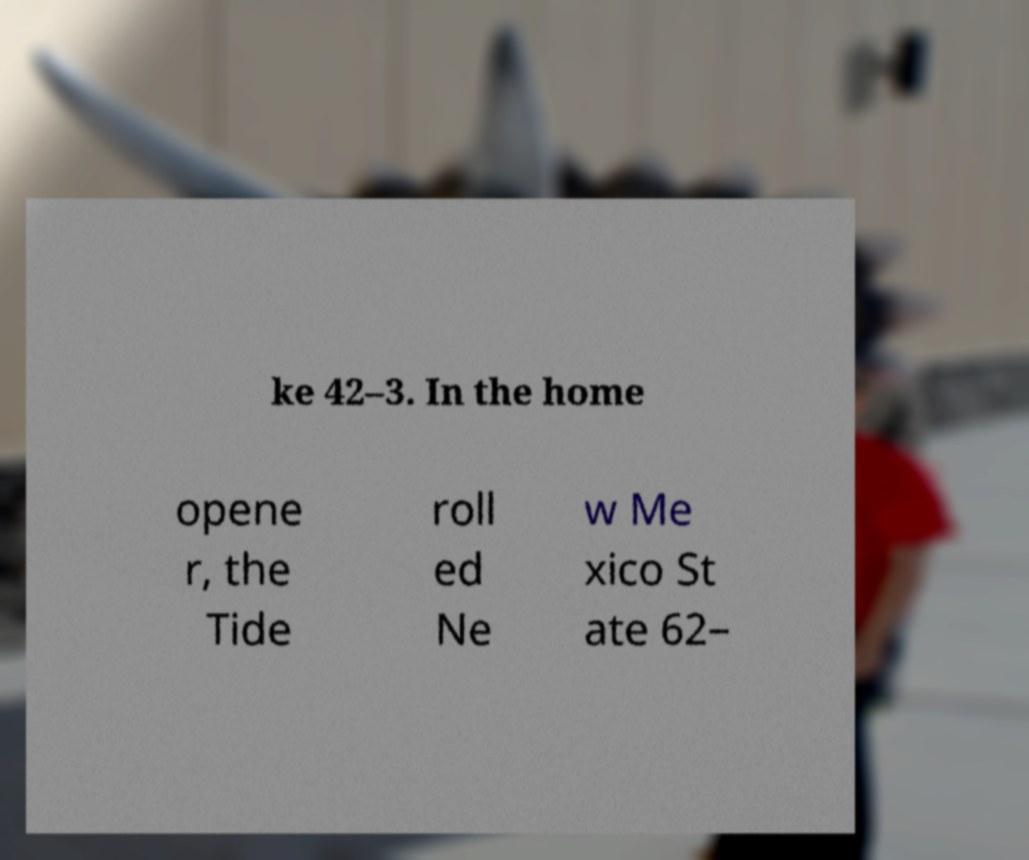Can you accurately transcribe the text from the provided image for me? ke 42–3. In the home opene r, the Tide roll ed Ne w Me xico St ate 62– 